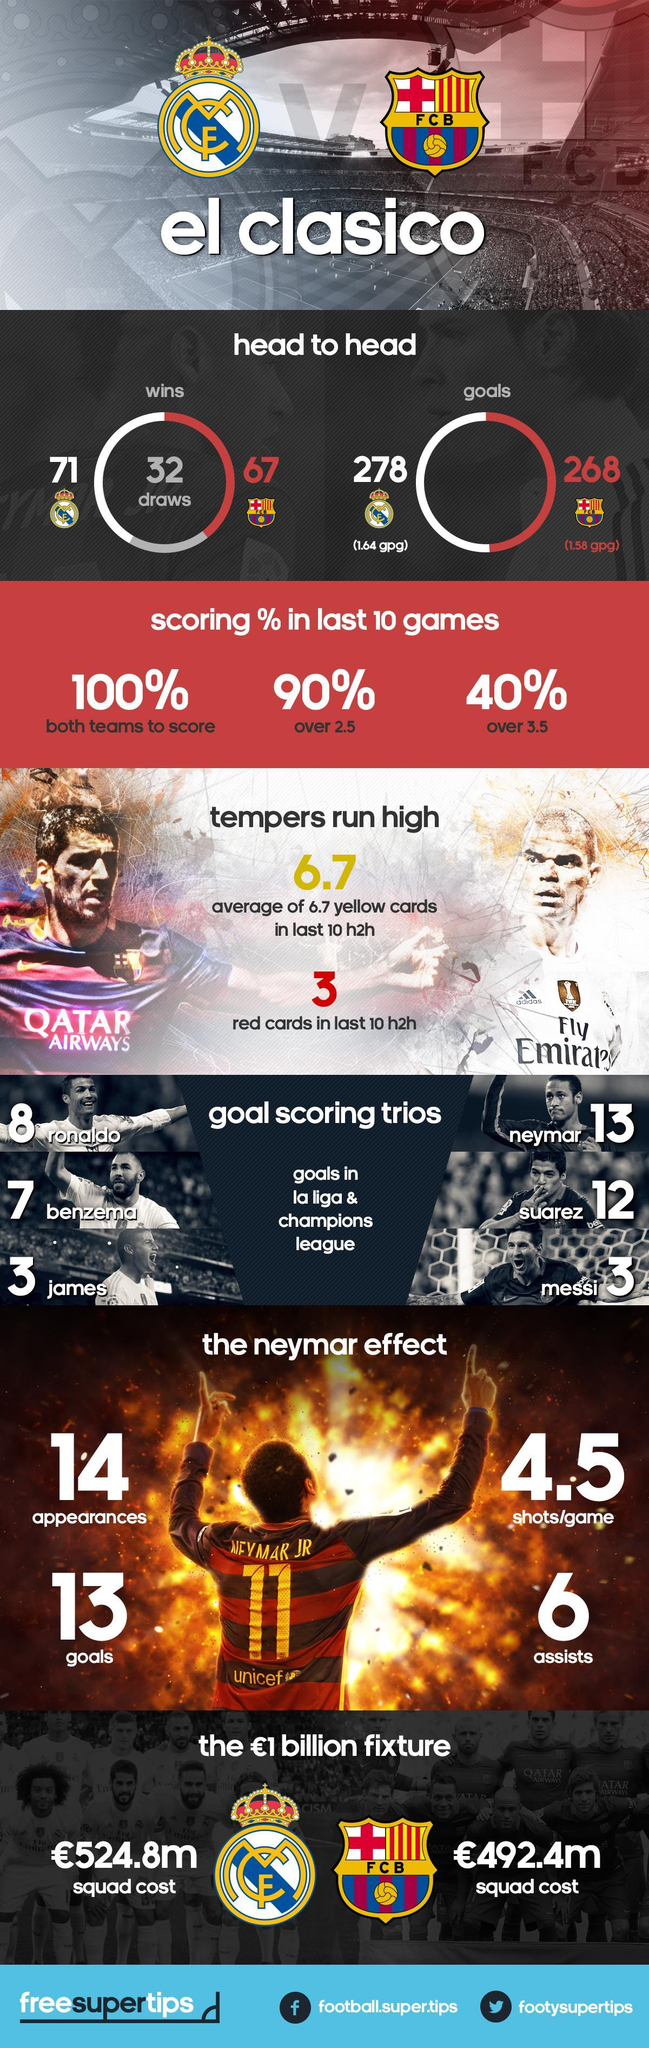How many goals were scored by the Real Madrid C.F. in El Clasico?
Answer the question with a short phrase. 278 Which airways has sponsored the Real Madrid C.F.? Fly Emirates How many times has Real Madrid C.F. won El Clasico? 71 Who has the highest win in the El Clasico? F C B How many times has Barcelona FC won El Clasico? 67 How many goals were scored by the Barcelona FC in El Clasico? 268 What is written in the jersey of Barcelona FC? QATAR AIRWAYS Who is the highest goal-scoring trio in Barcelona FC  other than Neymar? saurez, messi Who is the highest goal-scoring trio in Real Madrid C.F. other than Benzema? ronaldo, james 